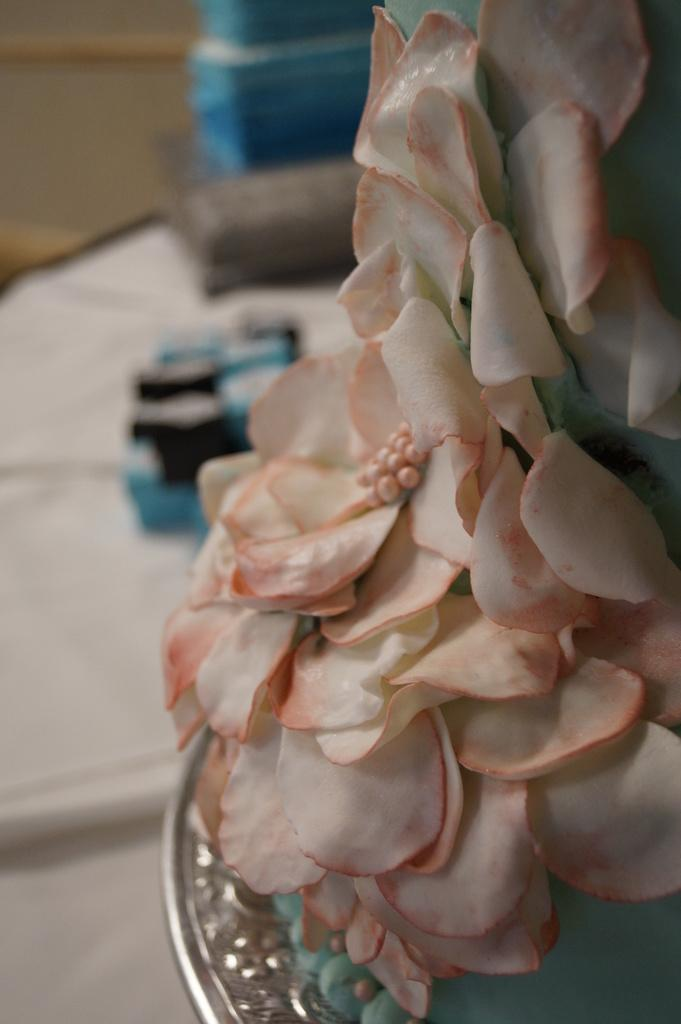What is the main subject of the image? The main subject of the image is a part of a cake. Where is the cake located in the image? The cake is placed on a surface in the image. What type of bone can be seen in the image? There is no bone present in the image; it features a part of a cake. What account number is associated with the cake in the image? There is no account number associated with the cake in the image. 